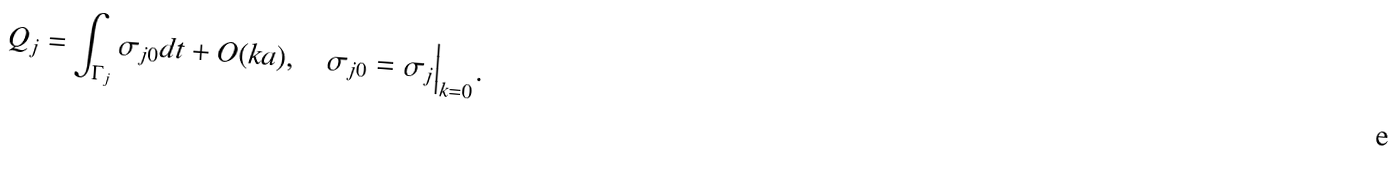<formula> <loc_0><loc_0><loc_500><loc_500>Q _ { j } = \int _ { \Gamma _ { j } } \sigma _ { j 0 } d t + O ( k a ) , \quad \sigma _ { j 0 } = \sigma _ { j } \Big | _ { k = 0 } .</formula> 